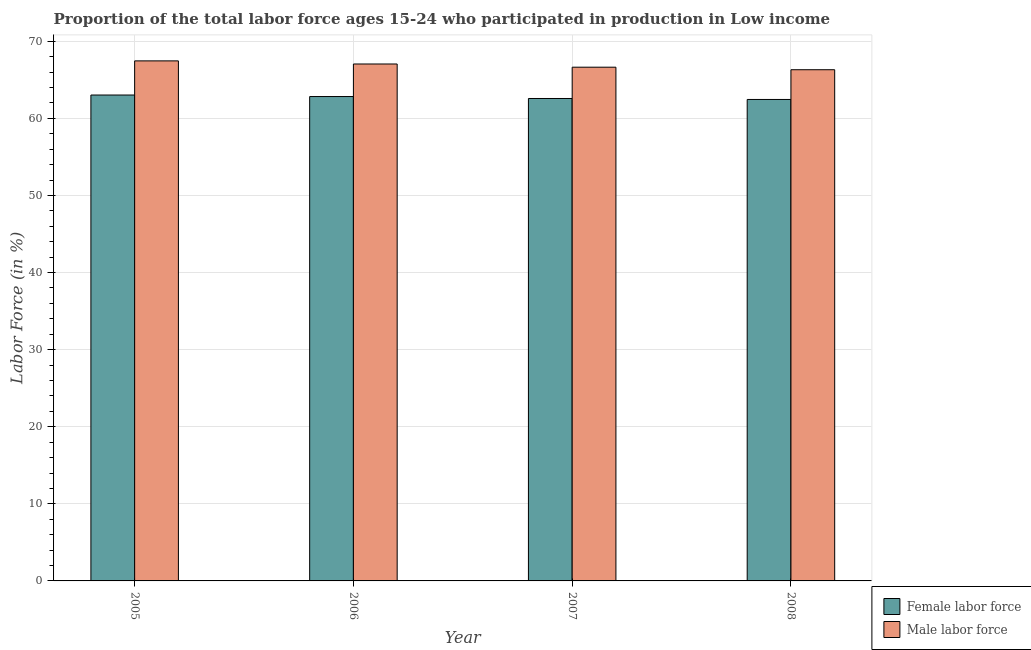How many different coloured bars are there?
Offer a very short reply. 2. How many groups of bars are there?
Offer a terse response. 4. Are the number of bars on each tick of the X-axis equal?
Your answer should be very brief. Yes. How many bars are there on the 4th tick from the left?
Provide a short and direct response. 2. How many bars are there on the 1st tick from the right?
Offer a very short reply. 2. In how many cases, is the number of bars for a given year not equal to the number of legend labels?
Keep it short and to the point. 0. What is the percentage of male labour force in 2006?
Offer a very short reply. 67.06. Across all years, what is the maximum percentage of female labor force?
Your answer should be compact. 63.03. Across all years, what is the minimum percentage of female labor force?
Offer a terse response. 62.46. In which year was the percentage of female labor force maximum?
Give a very brief answer. 2005. In which year was the percentage of female labor force minimum?
Give a very brief answer. 2008. What is the total percentage of male labour force in the graph?
Give a very brief answer. 267.48. What is the difference between the percentage of female labor force in 2005 and that in 2008?
Ensure brevity in your answer.  0.58. What is the difference between the percentage of female labor force in 2005 and the percentage of male labour force in 2008?
Provide a short and direct response. 0.58. What is the average percentage of female labor force per year?
Make the answer very short. 62.73. What is the ratio of the percentage of female labor force in 2007 to that in 2008?
Provide a short and direct response. 1. Is the percentage of male labour force in 2005 less than that in 2006?
Keep it short and to the point. No. What is the difference between the highest and the second highest percentage of female labor force?
Provide a succinct answer. 0.2. What is the difference between the highest and the lowest percentage of female labor force?
Offer a very short reply. 0.58. Is the sum of the percentage of female labor force in 2005 and 2008 greater than the maximum percentage of male labour force across all years?
Ensure brevity in your answer.  Yes. What does the 2nd bar from the left in 2005 represents?
Your answer should be compact. Male labor force. What does the 2nd bar from the right in 2008 represents?
Your answer should be very brief. Female labor force. How many years are there in the graph?
Ensure brevity in your answer.  4. What is the difference between two consecutive major ticks on the Y-axis?
Ensure brevity in your answer.  10. Are the values on the major ticks of Y-axis written in scientific E-notation?
Provide a short and direct response. No. Does the graph contain grids?
Provide a succinct answer. Yes. Where does the legend appear in the graph?
Provide a succinct answer. Bottom right. What is the title of the graph?
Offer a terse response. Proportion of the total labor force ages 15-24 who participated in production in Low income. Does "Crop" appear as one of the legend labels in the graph?
Ensure brevity in your answer.  No. What is the label or title of the Y-axis?
Your response must be concise. Labor Force (in %). What is the Labor Force (in %) in Female labor force in 2005?
Make the answer very short. 63.03. What is the Labor Force (in %) of Male labor force in 2005?
Give a very brief answer. 67.46. What is the Labor Force (in %) of Female labor force in 2006?
Offer a very short reply. 62.84. What is the Labor Force (in %) in Male labor force in 2006?
Ensure brevity in your answer.  67.06. What is the Labor Force (in %) of Female labor force in 2007?
Provide a short and direct response. 62.58. What is the Labor Force (in %) in Male labor force in 2007?
Offer a terse response. 66.64. What is the Labor Force (in %) in Female labor force in 2008?
Offer a terse response. 62.46. What is the Labor Force (in %) of Male labor force in 2008?
Offer a very short reply. 66.32. Across all years, what is the maximum Labor Force (in %) in Female labor force?
Your answer should be compact. 63.03. Across all years, what is the maximum Labor Force (in %) of Male labor force?
Your answer should be compact. 67.46. Across all years, what is the minimum Labor Force (in %) in Female labor force?
Offer a very short reply. 62.46. Across all years, what is the minimum Labor Force (in %) of Male labor force?
Offer a terse response. 66.32. What is the total Labor Force (in %) in Female labor force in the graph?
Provide a succinct answer. 250.91. What is the total Labor Force (in %) in Male labor force in the graph?
Your answer should be compact. 267.48. What is the difference between the Labor Force (in %) of Female labor force in 2005 and that in 2006?
Ensure brevity in your answer.  0.2. What is the difference between the Labor Force (in %) in Male labor force in 2005 and that in 2006?
Your answer should be very brief. 0.4. What is the difference between the Labor Force (in %) in Female labor force in 2005 and that in 2007?
Provide a short and direct response. 0.45. What is the difference between the Labor Force (in %) in Male labor force in 2005 and that in 2007?
Keep it short and to the point. 0.82. What is the difference between the Labor Force (in %) of Female labor force in 2005 and that in 2008?
Ensure brevity in your answer.  0.58. What is the difference between the Labor Force (in %) in Male labor force in 2005 and that in 2008?
Your answer should be very brief. 1.15. What is the difference between the Labor Force (in %) of Female labor force in 2006 and that in 2007?
Your answer should be compact. 0.25. What is the difference between the Labor Force (in %) of Male labor force in 2006 and that in 2007?
Keep it short and to the point. 0.42. What is the difference between the Labor Force (in %) in Female labor force in 2006 and that in 2008?
Give a very brief answer. 0.38. What is the difference between the Labor Force (in %) of Male labor force in 2006 and that in 2008?
Your answer should be very brief. 0.74. What is the difference between the Labor Force (in %) of Female labor force in 2007 and that in 2008?
Offer a very short reply. 0.12. What is the difference between the Labor Force (in %) of Male labor force in 2007 and that in 2008?
Your answer should be compact. 0.33. What is the difference between the Labor Force (in %) of Female labor force in 2005 and the Labor Force (in %) of Male labor force in 2006?
Your answer should be compact. -4.02. What is the difference between the Labor Force (in %) of Female labor force in 2005 and the Labor Force (in %) of Male labor force in 2007?
Keep it short and to the point. -3.61. What is the difference between the Labor Force (in %) in Female labor force in 2005 and the Labor Force (in %) in Male labor force in 2008?
Offer a very short reply. -3.28. What is the difference between the Labor Force (in %) in Female labor force in 2006 and the Labor Force (in %) in Male labor force in 2007?
Provide a succinct answer. -3.81. What is the difference between the Labor Force (in %) in Female labor force in 2006 and the Labor Force (in %) in Male labor force in 2008?
Ensure brevity in your answer.  -3.48. What is the difference between the Labor Force (in %) of Female labor force in 2007 and the Labor Force (in %) of Male labor force in 2008?
Provide a succinct answer. -3.73. What is the average Labor Force (in %) of Female labor force per year?
Provide a short and direct response. 62.73. What is the average Labor Force (in %) in Male labor force per year?
Your answer should be compact. 66.87. In the year 2005, what is the difference between the Labor Force (in %) in Female labor force and Labor Force (in %) in Male labor force?
Give a very brief answer. -4.43. In the year 2006, what is the difference between the Labor Force (in %) of Female labor force and Labor Force (in %) of Male labor force?
Your answer should be compact. -4.22. In the year 2007, what is the difference between the Labor Force (in %) in Female labor force and Labor Force (in %) in Male labor force?
Offer a very short reply. -4.06. In the year 2008, what is the difference between the Labor Force (in %) in Female labor force and Labor Force (in %) in Male labor force?
Ensure brevity in your answer.  -3.86. What is the ratio of the Labor Force (in %) in Male labor force in 2005 to that in 2007?
Offer a very short reply. 1.01. What is the ratio of the Labor Force (in %) in Female labor force in 2005 to that in 2008?
Offer a very short reply. 1.01. What is the ratio of the Labor Force (in %) of Male labor force in 2005 to that in 2008?
Offer a terse response. 1.02. What is the ratio of the Labor Force (in %) in Female labor force in 2006 to that in 2007?
Give a very brief answer. 1. What is the ratio of the Labor Force (in %) in Male labor force in 2006 to that in 2007?
Your answer should be very brief. 1.01. What is the ratio of the Labor Force (in %) in Male labor force in 2006 to that in 2008?
Offer a terse response. 1.01. What is the ratio of the Labor Force (in %) in Female labor force in 2007 to that in 2008?
Make the answer very short. 1. What is the difference between the highest and the second highest Labor Force (in %) of Female labor force?
Keep it short and to the point. 0.2. What is the difference between the highest and the second highest Labor Force (in %) of Male labor force?
Your answer should be compact. 0.4. What is the difference between the highest and the lowest Labor Force (in %) of Female labor force?
Give a very brief answer. 0.58. What is the difference between the highest and the lowest Labor Force (in %) of Male labor force?
Ensure brevity in your answer.  1.15. 